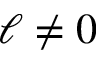<formula> <loc_0><loc_0><loc_500><loc_500>\ell \neq 0</formula> 